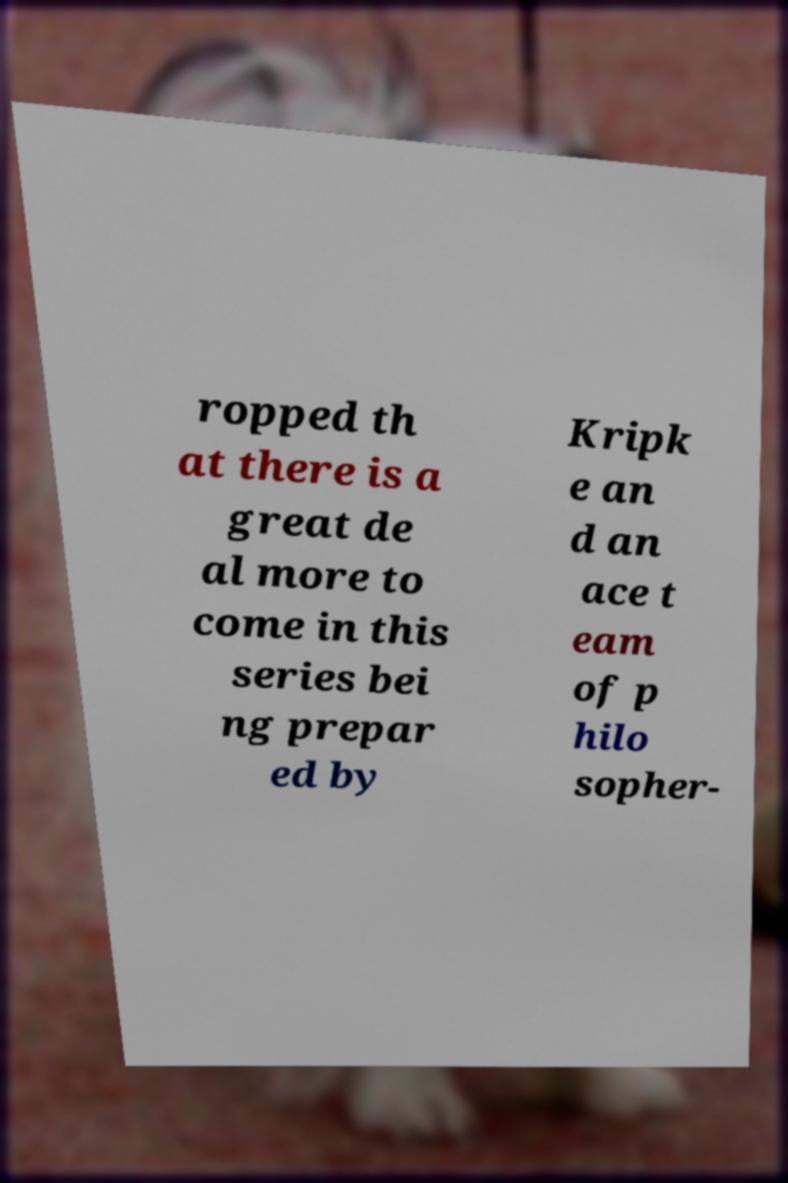For documentation purposes, I need the text within this image transcribed. Could you provide that? ropped th at there is a great de al more to come in this series bei ng prepar ed by Kripk e an d an ace t eam of p hilo sopher- 